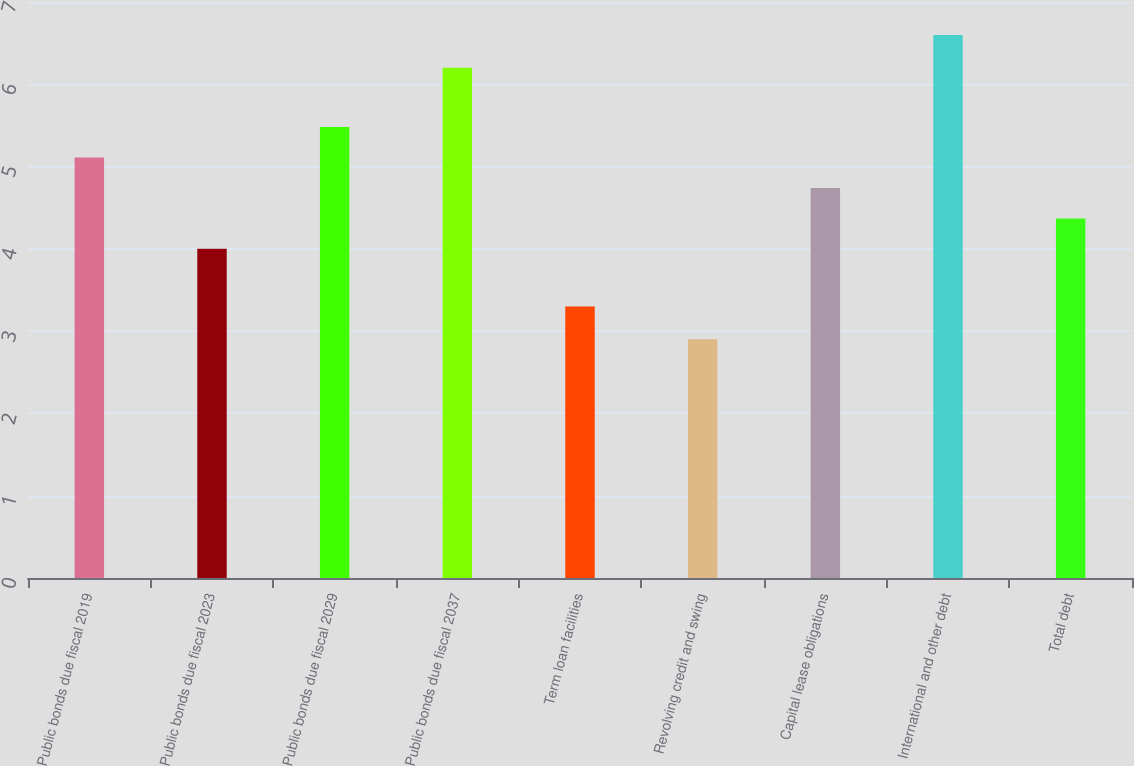<chart> <loc_0><loc_0><loc_500><loc_500><bar_chart><fcel>Public bonds due fiscal 2019<fcel>Public bonds due fiscal 2023<fcel>Public bonds due fiscal 2029<fcel>Public bonds due fiscal 2037<fcel>Term loan facilities<fcel>Revolving credit and swing<fcel>Capital lease obligations<fcel>International and other debt<fcel>Total debt<nl><fcel>5.11<fcel>4<fcel>5.48<fcel>6.2<fcel>3.3<fcel>2.9<fcel>4.74<fcel>6.6<fcel>4.37<nl></chart> 